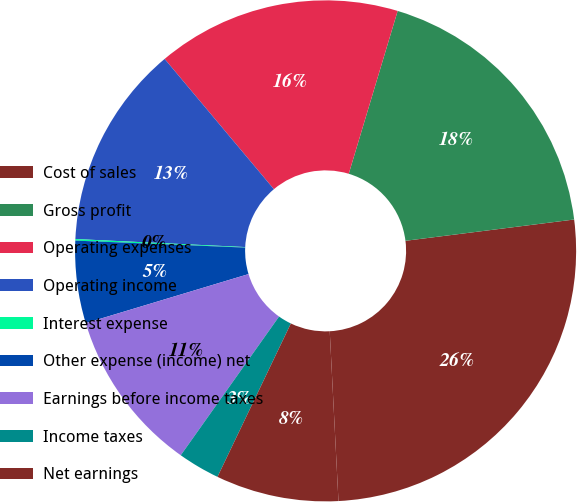<chart> <loc_0><loc_0><loc_500><loc_500><pie_chart><fcel>Cost of sales<fcel>Gross profit<fcel>Operating expenses<fcel>Operating income<fcel>Interest expense<fcel>Other expense (income) net<fcel>Earnings before income taxes<fcel>Income taxes<fcel>Net earnings<nl><fcel>26.18%<fcel>18.36%<fcel>15.75%<fcel>13.14%<fcel>0.1%<fcel>5.31%<fcel>10.53%<fcel>2.71%<fcel>7.92%<nl></chart> 